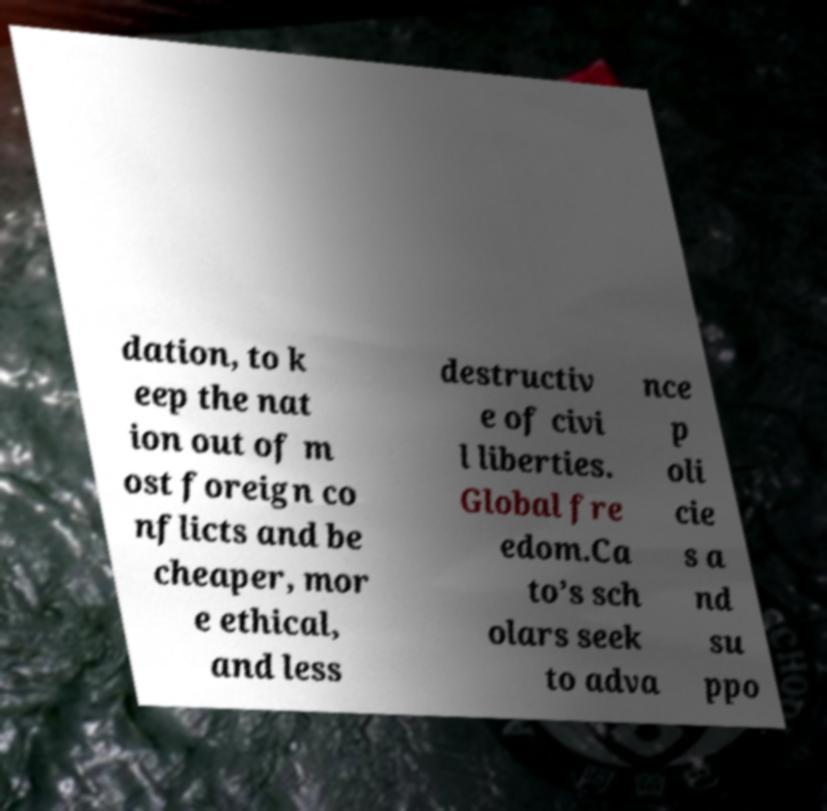Please identify and transcribe the text found in this image. dation, to k eep the nat ion out of m ost foreign co nflicts and be cheaper, mor e ethical, and less destructiv e of civi l liberties. Global fre edom.Ca to’s sch olars seek to adva nce p oli cie s a nd su ppo 